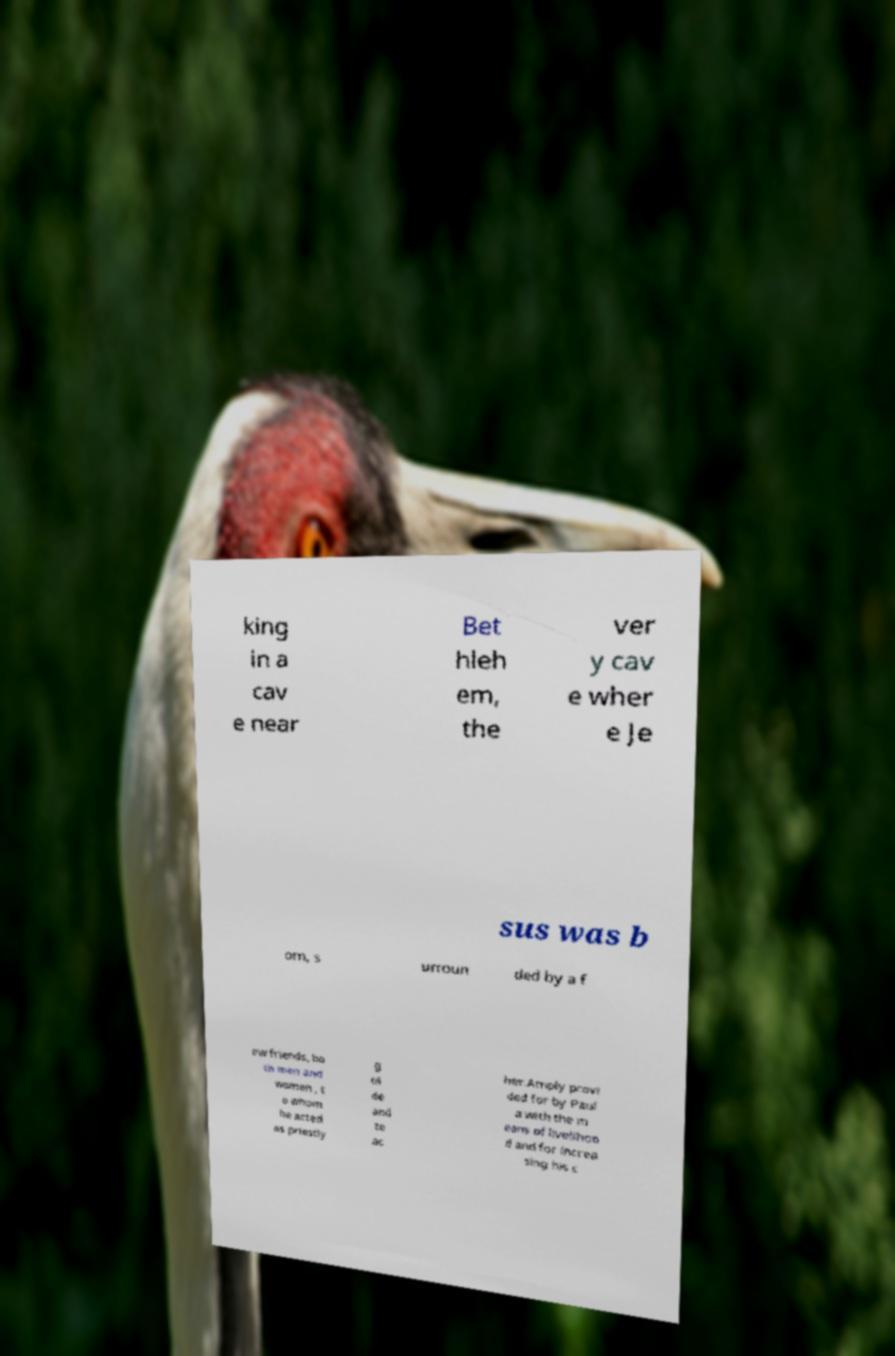Please identify and transcribe the text found in this image. king in a cav e near Bet hleh em, the ver y cav e wher e Je sus was b orn, s urroun ded by a f ew friends, bo th men and women , t o whom he acted as priestly g ui de and te ac her.Amply provi ded for by Paul a with the m eans of livelihoo d and for increa sing his c 